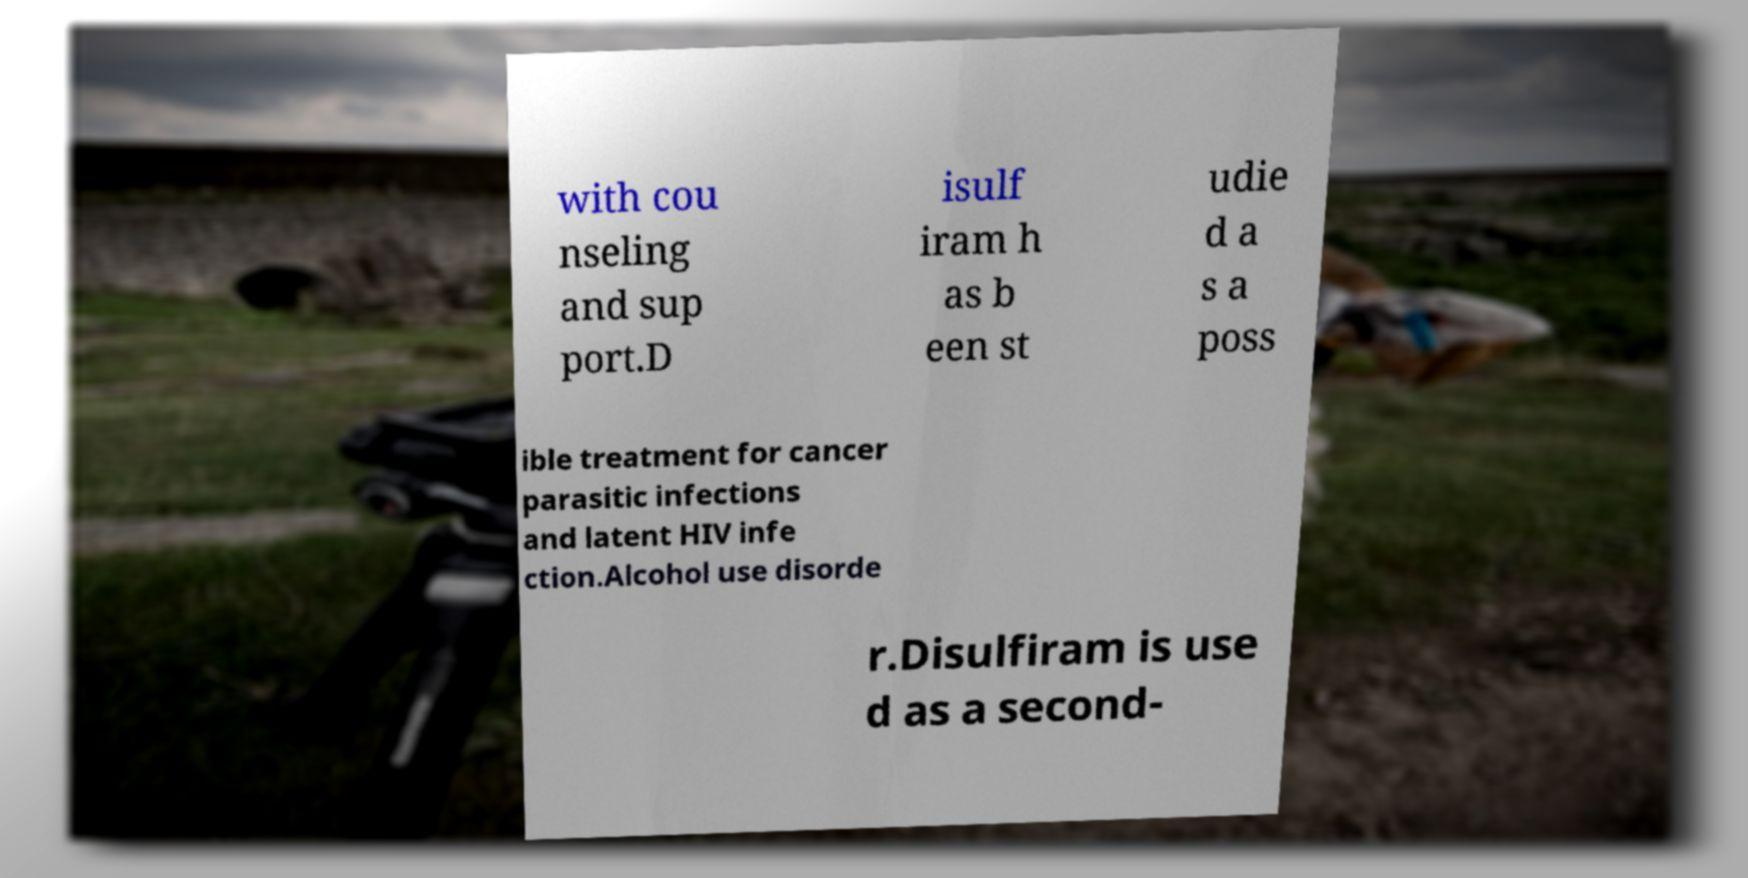What messages or text are displayed in this image? I need them in a readable, typed format. with cou nseling and sup port.D isulf iram h as b een st udie d a s a poss ible treatment for cancer parasitic infections and latent HIV infe ction.Alcohol use disorde r.Disulfiram is use d as a second- 